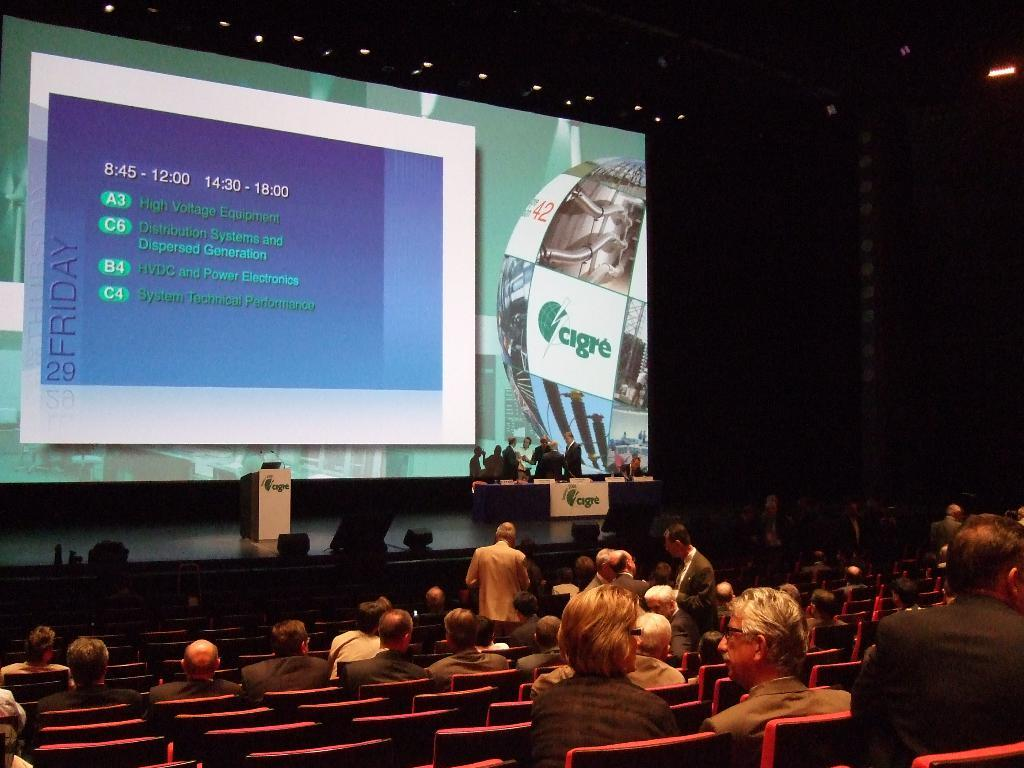<image>
Write a terse but informative summary of the picture. Several people in an auditorium are watching a presentation by cigre. 